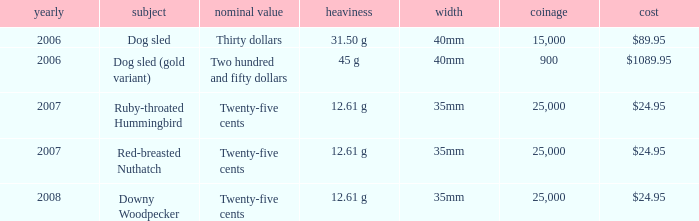What is the MIntage after 2006 of the Ruby-Throated Hummingbird Theme coin? 25000.0. 